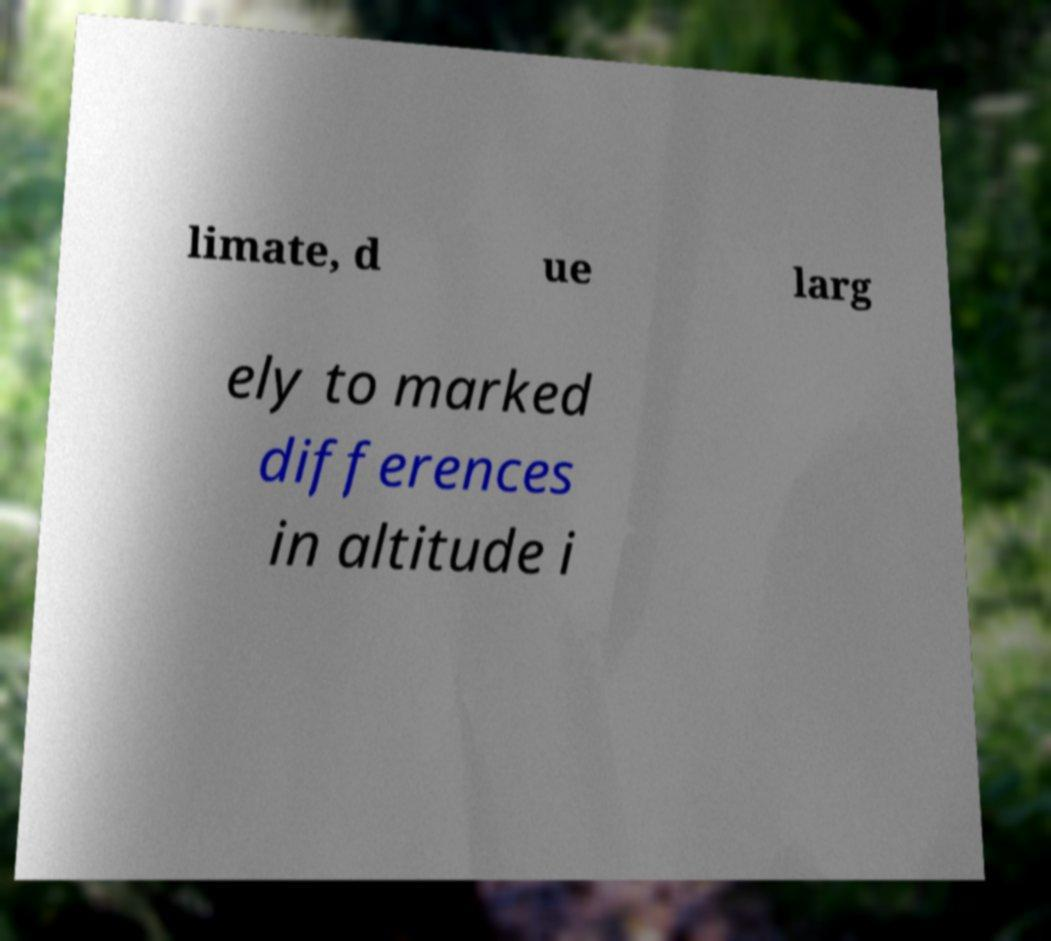Could you assist in decoding the text presented in this image and type it out clearly? limate, d ue larg ely to marked differences in altitude i 